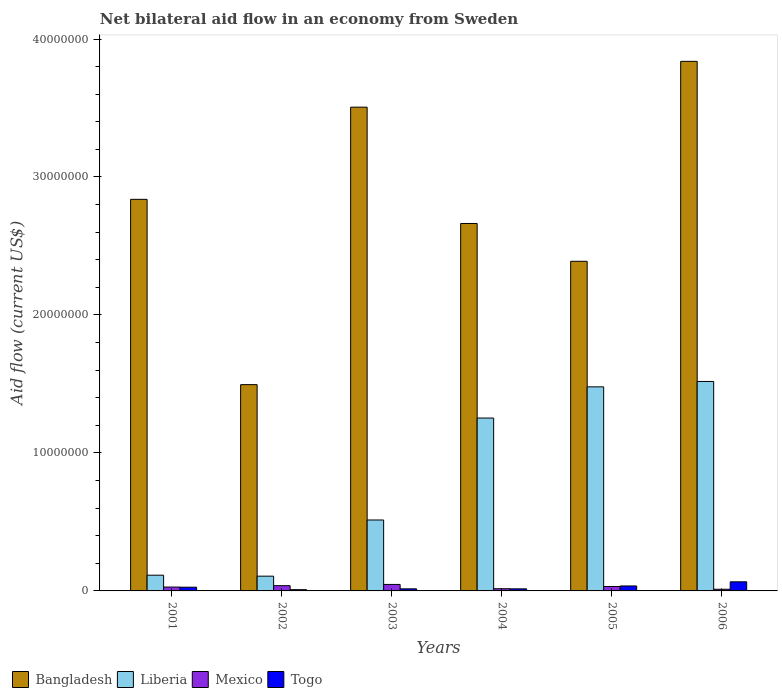How many different coloured bars are there?
Ensure brevity in your answer.  4. How many groups of bars are there?
Your answer should be very brief. 6. Are the number of bars per tick equal to the number of legend labels?
Give a very brief answer. Yes. Are the number of bars on each tick of the X-axis equal?
Your answer should be very brief. Yes. How many bars are there on the 6th tick from the left?
Your response must be concise. 4. How many bars are there on the 2nd tick from the right?
Keep it short and to the point. 4. In how many cases, is the number of bars for a given year not equal to the number of legend labels?
Provide a short and direct response. 0. What is the net bilateral aid flow in Bangladesh in 2003?
Your answer should be compact. 3.51e+07. Across all years, what is the maximum net bilateral aid flow in Mexico?
Offer a very short reply. 4.70e+05. In which year was the net bilateral aid flow in Bangladesh minimum?
Your answer should be compact. 2002. What is the total net bilateral aid flow in Mexico in the graph?
Offer a very short reply. 1.73e+06. What is the difference between the net bilateral aid flow in Togo in 2001 and that in 2006?
Your answer should be very brief. -3.90e+05. What is the difference between the net bilateral aid flow in Mexico in 2001 and the net bilateral aid flow in Togo in 2006?
Give a very brief answer. -3.80e+05. What is the average net bilateral aid flow in Bangladesh per year?
Make the answer very short. 2.79e+07. In the year 2001, what is the difference between the net bilateral aid flow in Mexico and net bilateral aid flow in Bangladesh?
Your answer should be very brief. -2.81e+07. In how many years, is the net bilateral aid flow in Mexico greater than 20000000 US$?
Keep it short and to the point. 0. What is the ratio of the net bilateral aid flow in Bangladesh in 2001 to that in 2003?
Provide a succinct answer. 0.81. Is the net bilateral aid flow in Togo in 2001 less than that in 2005?
Keep it short and to the point. Yes. What is the difference between the highest and the second highest net bilateral aid flow in Bangladesh?
Give a very brief answer. 3.32e+06. What is the difference between the highest and the lowest net bilateral aid flow in Togo?
Offer a very short reply. 5.70e+05. Is the sum of the net bilateral aid flow in Liberia in 2001 and 2004 greater than the maximum net bilateral aid flow in Mexico across all years?
Make the answer very short. Yes. What does the 1st bar from the left in 2004 represents?
Your answer should be compact. Bangladesh. Is it the case that in every year, the sum of the net bilateral aid flow in Togo and net bilateral aid flow in Liberia is greater than the net bilateral aid flow in Bangladesh?
Your answer should be very brief. No. Are all the bars in the graph horizontal?
Provide a short and direct response. No. Are the values on the major ticks of Y-axis written in scientific E-notation?
Your answer should be very brief. No. Where does the legend appear in the graph?
Your answer should be very brief. Bottom left. How many legend labels are there?
Provide a succinct answer. 4. How are the legend labels stacked?
Offer a terse response. Horizontal. What is the title of the graph?
Your answer should be compact. Net bilateral aid flow in an economy from Sweden. What is the label or title of the Y-axis?
Ensure brevity in your answer.  Aid flow (current US$). What is the Aid flow (current US$) of Bangladesh in 2001?
Your answer should be very brief. 2.84e+07. What is the Aid flow (current US$) of Liberia in 2001?
Make the answer very short. 1.14e+06. What is the Aid flow (current US$) of Bangladesh in 2002?
Offer a terse response. 1.50e+07. What is the Aid flow (current US$) of Liberia in 2002?
Give a very brief answer. 1.07e+06. What is the Aid flow (current US$) of Mexico in 2002?
Your answer should be compact. 3.80e+05. What is the Aid flow (current US$) of Togo in 2002?
Provide a short and direct response. 9.00e+04. What is the Aid flow (current US$) in Bangladesh in 2003?
Offer a terse response. 3.51e+07. What is the Aid flow (current US$) in Liberia in 2003?
Your response must be concise. 5.14e+06. What is the Aid flow (current US$) in Togo in 2003?
Provide a short and direct response. 1.50e+05. What is the Aid flow (current US$) of Bangladesh in 2004?
Your answer should be compact. 2.66e+07. What is the Aid flow (current US$) of Liberia in 2004?
Your answer should be compact. 1.25e+07. What is the Aid flow (current US$) of Bangladesh in 2005?
Your answer should be compact. 2.39e+07. What is the Aid flow (current US$) in Liberia in 2005?
Make the answer very short. 1.48e+07. What is the Aid flow (current US$) in Mexico in 2005?
Your answer should be compact. 3.20e+05. What is the Aid flow (current US$) of Bangladesh in 2006?
Your answer should be very brief. 3.84e+07. What is the Aid flow (current US$) of Liberia in 2006?
Your answer should be compact. 1.52e+07. What is the Aid flow (current US$) of Mexico in 2006?
Your response must be concise. 1.20e+05. Across all years, what is the maximum Aid flow (current US$) in Bangladesh?
Provide a short and direct response. 3.84e+07. Across all years, what is the maximum Aid flow (current US$) in Liberia?
Your response must be concise. 1.52e+07. Across all years, what is the maximum Aid flow (current US$) of Mexico?
Your response must be concise. 4.70e+05. Across all years, what is the minimum Aid flow (current US$) in Bangladesh?
Offer a terse response. 1.50e+07. Across all years, what is the minimum Aid flow (current US$) of Liberia?
Provide a short and direct response. 1.07e+06. Across all years, what is the minimum Aid flow (current US$) of Togo?
Ensure brevity in your answer.  9.00e+04. What is the total Aid flow (current US$) in Bangladesh in the graph?
Offer a very short reply. 1.67e+08. What is the total Aid flow (current US$) in Liberia in the graph?
Offer a very short reply. 4.98e+07. What is the total Aid flow (current US$) in Mexico in the graph?
Provide a succinct answer. 1.73e+06. What is the total Aid flow (current US$) of Togo in the graph?
Keep it short and to the point. 1.68e+06. What is the difference between the Aid flow (current US$) of Bangladesh in 2001 and that in 2002?
Provide a short and direct response. 1.34e+07. What is the difference between the Aid flow (current US$) in Liberia in 2001 and that in 2002?
Give a very brief answer. 7.00e+04. What is the difference between the Aid flow (current US$) of Mexico in 2001 and that in 2002?
Make the answer very short. -1.00e+05. What is the difference between the Aid flow (current US$) of Bangladesh in 2001 and that in 2003?
Your answer should be very brief. -6.68e+06. What is the difference between the Aid flow (current US$) of Mexico in 2001 and that in 2003?
Your response must be concise. -1.90e+05. What is the difference between the Aid flow (current US$) of Togo in 2001 and that in 2003?
Your answer should be very brief. 1.20e+05. What is the difference between the Aid flow (current US$) in Bangladesh in 2001 and that in 2004?
Provide a succinct answer. 1.75e+06. What is the difference between the Aid flow (current US$) in Liberia in 2001 and that in 2004?
Ensure brevity in your answer.  -1.14e+07. What is the difference between the Aid flow (current US$) of Mexico in 2001 and that in 2004?
Offer a very short reply. 1.20e+05. What is the difference between the Aid flow (current US$) of Bangladesh in 2001 and that in 2005?
Ensure brevity in your answer.  4.49e+06. What is the difference between the Aid flow (current US$) of Liberia in 2001 and that in 2005?
Your answer should be very brief. -1.36e+07. What is the difference between the Aid flow (current US$) in Bangladesh in 2001 and that in 2006?
Provide a short and direct response. -1.00e+07. What is the difference between the Aid flow (current US$) in Liberia in 2001 and that in 2006?
Provide a succinct answer. -1.40e+07. What is the difference between the Aid flow (current US$) of Togo in 2001 and that in 2006?
Your response must be concise. -3.90e+05. What is the difference between the Aid flow (current US$) in Bangladesh in 2002 and that in 2003?
Your response must be concise. -2.01e+07. What is the difference between the Aid flow (current US$) of Liberia in 2002 and that in 2003?
Offer a very short reply. -4.07e+06. What is the difference between the Aid flow (current US$) of Bangladesh in 2002 and that in 2004?
Make the answer very short. -1.17e+07. What is the difference between the Aid flow (current US$) in Liberia in 2002 and that in 2004?
Give a very brief answer. -1.15e+07. What is the difference between the Aid flow (current US$) of Mexico in 2002 and that in 2004?
Provide a succinct answer. 2.20e+05. What is the difference between the Aid flow (current US$) of Togo in 2002 and that in 2004?
Make the answer very short. -6.00e+04. What is the difference between the Aid flow (current US$) in Bangladesh in 2002 and that in 2005?
Ensure brevity in your answer.  -8.94e+06. What is the difference between the Aid flow (current US$) of Liberia in 2002 and that in 2005?
Make the answer very short. -1.37e+07. What is the difference between the Aid flow (current US$) of Bangladesh in 2002 and that in 2006?
Provide a succinct answer. -2.34e+07. What is the difference between the Aid flow (current US$) of Liberia in 2002 and that in 2006?
Offer a very short reply. -1.41e+07. What is the difference between the Aid flow (current US$) of Mexico in 2002 and that in 2006?
Your response must be concise. 2.60e+05. What is the difference between the Aid flow (current US$) in Togo in 2002 and that in 2006?
Provide a succinct answer. -5.70e+05. What is the difference between the Aid flow (current US$) of Bangladesh in 2003 and that in 2004?
Your answer should be very brief. 8.43e+06. What is the difference between the Aid flow (current US$) in Liberia in 2003 and that in 2004?
Your answer should be very brief. -7.39e+06. What is the difference between the Aid flow (current US$) of Mexico in 2003 and that in 2004?
Offer a very short reply. 3.10e+05. What is the difference between the Aid flow (current US$) in Bangladesh in 2003 and that in 2005?
Keep it short and to the point. 1.12e+07. What is the difference between the Aid flow (current US$) in Liberia in 2003 and that in 2005?
Your response must be concise. -9.65e+06. What is the difference between the Aid flow (current US$) of Mexico in 2003 and that in 2005?
Make the answer very short. 1.50e+05. What is the difference between the Aid flow (current US$) of Bangladesh in 2003 and that in 2006?
Provide a short and direct response. -3.32e+06. What is the difference between the Aid flow (current US$) in Liberia in 2003 and that in 2006?
Ensure brevity in your answer.  -1.00e+07. What is the difference between the Aid flow (current US$) of Mexico in 2003 and that in 2006?
Your answer should be very brief. 3.50e+05. What is the difference between the Aid flow (current US$) of Togo in 2003 and that in 2006?
Offer a terse response. -5.10e+05. What is the difference between the Aid flow (current US$) in Bangladesh in 2004 and that in 2005?
Your answer should be very brief. 2.74e+06. What is the difference between the Aid flow (current US$) of Liberia in 2004 and that in 2005?
Offer a very short reply. -2.26e+06. What is the difference between the Aid flow (current US$) of Mexico in 2004 and that in 2005?
Offer a terse response. -1.60e+05. What is the difference between the Aid flow (current US$) in Bangladesh in 2004 and that in 2006?
Ensure brevity in your answer.  -1.18e+07. What is the difference between the Aid flow (current US$) in Liberia in 2004 and that in 2006?
Ensure brevity in your answer.  -2.65e+06. What is the difference between the Aid flow (current US$) in Mexico in 2004 and that in 2006?
Ensure brevity in your answer.  4.00e+04. What is the difference between the Aid flow (current US$) in Togo in 2004 and that in 2006?
Offer a very short reply. -5.10e+05. What is the difference between the Aid flow (current US$) in Bangladesh in 2005 and that in 2006?
Your answer should be very brief. -1.45e+07. What is the difference between the Aid flow (current US$) in Liberia in 2005 and that in 2006?
Offer a very short reply. -3.90e+05. What is the difference between the Aid flow (current US$) in Bangladesh in 2001 and the Aid flow (current US$) in Liberia in 2002?
Your response must be concise. 2.73e+07. What is the difference between the Aid flow (current US$) of Bangladesh in 2001 and the Aid flow (current US$) of Mexico in 2002?
Ensure brevity in your answer.  2.80e+07. What is the difference between the Aid flow (current US$) of Bangladesh in 2001 and the Aid flow (current US$) of Togo in 2002?
Make the answer very short. 2.83e+07. What is the difference between the Aid flow (current US$) of Liberia in 2001 and the Aid flow (current US$) of Mexico in 2002?
Offer a very short reply. 7.60e+05. What is the difference between the Aid flow (current US$) of Liberia in 2001 and the Aid flow (current US$) of Togo in 2002?
Make the answer very short. 1.05e+06. What is the difference between the Aid flow (current US$) in Mexico in 2001 and the Aid flow (current US$) in Togo in 2002?
Ensure brevity in your answer.  1.90e+05. What is the difference between the Aid flow (current US$) in Bangladesh in 2001 and the Aid flow (current US$) in Liberia in 2003?
Offer a terse response. 2.32e+07. What is the difference between the Aid flow (current US$) in Bangladesh in 2001 and the Aid flow (current US$) in Mexico in 2003?
Provide a short and direct response. 2.79e+07. What is the difference between the Aid flow (current US$) of Bangladesh in 2001 and the Aid flow (current US$) of Togo in 2003?
Keep it short and to the point. 2.82e+07. What is the difference between the Aid flow (current US$) in Liberia in 2001 and the Aid flow (current US$) in Mexico in 2003?
Provide a succinct answer. 6.70e+05. What is the difference between the Aid flow (current US$) of Liberia in 2001 and the Aid flow (current US$) of Togo in 2003?
Your response must be concise. 9.90e+05. What is the difference between the Aid flow (current US$) of Mexico in 2001 and the Aid flow (current US$) of Togo in 2003?
Provide a succinct answer. 1.30e+05. What is the difference between the Aid flow (current US$) in Bangladesh in 2001 and the Aid flow (current US$) in Liberia in 2004?
Offer a terse response. 1.58e+07. What is the difference between the Aid flow (current US$) of Bangladesh in 2001 and the Aid flow (current US$) of Mexico in 2004?
Your answer should be very brief. 2.82e+07. What is the difference between the Aid flow (current US$) in Bangladesh in 2001 and the Aid flow (current US$) in Togo in 2004?
Your response must be concise. 2.82e+07. What is the difference between the Aid flow (current US$) of Liberia in 2001 and the Aid flow (current US$) of Mexico in 2004?
Provide a short and direct response. 9.80e+05. What is the difference between the Aid flow (current US$) of Liberia in 2001 and the Aid flow (current US$) of Togo in 2004?
Offer a terse response. 9.90e+05. What is the difference between the Aid flow (current US$) in Bangladesh in 2001 and the Aid flow (current US$) in Liberia in 2005?
Your answer should be compact. 1.36e+07. What is the difference between the Aid flow (current US$) in Bangladesh in 2001 and the Aid flow (current US$) in Mexico in 2005?
Provide a short and direct response. 2.81e+07. What is the difference between the Aid flow (current US$) of Bangladesh in 2001 and the Aid flow (current US$) of Togo in 2005?
Keep it short and to the point. 2.80e+07. What is the difference between the Aid flow (current US$) in Liberia in 2001 and the Aid flow (current US$) in Mexico in 2005?
Provide a succinct answer. 8.20e+05. What is the difference between the Aid flow (current US$) in Liberia in 2001 and the Aid flow (current US$) in Togo in 2005?
Keep it short and to the point. 7.80e+05. What is the difference between the Aid flow (current US$) of Mexico in 2001 and the Aid flow (current US$) of Togo in 2005?
Give a very brief answer. -8.00e+04. What is the difference between the Aid flow (current US$) of Bangladesh in 2001 and the Aid flow (current US$) of Liberia in 2006?
Your answer should be compact. 1.32e+07. What is the difference between the Aid flow (current US$) of Bangladesh in 2001 and the Aid flow (current US$) of Mexico in 2006?
Make the answer very short. 2.83e+07. What is the difference between the Aid flow (current US$) of Bangladesh in 2001 and the Aid flow (current US$) of Togo in 2006?
Your response must be concise. 2.77e+07. What is the difference between the Aid flow (current US$) of Liberia in 2001 and the Aid flow (current US$) of Mexico in 2006?
Keep it short and to the point. 1.02e+06. What is the difference between the Aid flow (current US$) in Mexico in 2001 and the Aid flow (current US$) in Togo in 2006?
Your answer should be very brief. -3.80e+05. What is the difference between the Aid flow (current US$) in Bangladesh in 2002 and the Aid flow (current US$) in Liberia in 2003?
Make the answer very short. 9.81e+06. What is the difference between the Aid flow (current US$) of Bangladesh in 2002 and the Aid flow (current US$) of Mexico in 2003?
Offer a very short reply. 1.45e+07. What is the difference between the Aid flow (current US$) of Bangladesh in 2002 and the Aid flow (current US$) of Togo in 2003?
Your response must be concise. 1.48e+07. What is the difference between the Aid flow (current US$) of Liberia in 2002 and the Aid flow (current US$) of Mexico in 2003?
Provide a succinct answer. 6.00e+05. What is the difference between the Aid flow (current US$) of Liberia in 2002 and the Aid flow (current US$) of Togo in 2003?
Ensure brevity in your answer.  9.20e+05. What is the difference between the Aid flow (current US$) in Mexico in 2002 and the Aid flow (current US$) in Togo in 2003?
Ensure brevity in your answer.  2.30e+05. What is the difference between the Aid flow (current US$) of Bangladesh in 2002 and the Aid flow (current US$) of Liberia in 2004?
Your response must be concise. 2.42e+06. What is the difference between the Aid flow (current US$) of Bangladesh in 2002 and the Aid flow (current US$) of Mexico in 2004?
Ensure brevity in your answer.  1.48e+07. What is the difference between the Aid flow (current US$) of Bangladesh in 2002 and the Aid flow (current US$) of Togo in 2004?
Keep it short and to the point. 1.48e+07. What is the difference between the Aid flow (current US$) of Liberia in 2002 and the Aid flow (current US$) of Mexico in 2004?
Keep it short and to the point. 9.10e+05. What is the difference between the Aid flow (current US$) of Liberia in 2002 and the Aid flow (current US$) of Togo in 2004?
Ensure brevity in your answer.  9.20e+05. What is the difference between the Aid flow (current US$) in Mexico in 2002 and the Aid flow (current US$) in Togo in 2004?
Your answer should be very brief. 2.30e+05. What is the difference between the Aid flow (current US$) in Bangladesh in 2002 and the Aid flow (current US$) in Liberia in 2005?
Your answer should be very brief. 1.60e+05. What is the difference between the Aid flow (current US$) in Bangladesh in 2002 and the Aid flow (current US$) in Mexico in 2005?
Give a very brief answer. 1.46e+07. What is the difference between the Aid flow (current US$) of Bangladesh in 2002 and the Aid flow (current US$) of Togo in 2005?
Offer a terse response. 1.46e+07. What is the difference between the Aid flow (current US$) of Liberia in 2002 and the Aid flow (current US$) of Mexico in 2005?
Your answer should be very brief. 7.50e+05. What is the difference between the Aid flow (current US$) of Liberia in 2002 and the Aid flow (current US$) of Togo in 2005?
Your response must be concise. 7.10e+05. What is the difference between the Aid flow (current US$) of Mexico in 2002 and the Aid flow (current US$) of Togo in 2005?
Your response must be concise. 2.00e+04. What is the difference between the Aid flow (current US$) of Bangladesh in 2002 and the Aid flow (current US$) of Mexico in 2006?
Your answer should be very brief. 1.48e+07. What is the difference between the Aid flow (current US$) of Bangladesh in 2002 and the Aid flow (current US$) of Togo in 2006?
Give a very brief answer. 1.43e+07. What is the difference between the Aid flow (current US$) in Liberia in 2002 and the Aid flow (current US$) in Mexico in 2006?
Your response must be concise. 9.50e+05. What is the difference between the Aid flow (current US$) in Liberia in 2002 and the Aid flow (current US$) in Togo in 2006?
Give a very brief answer. 4.10e+05. What is the difference between the Aid flow (current US$) of Mexico in 2002 and the Aid flow (current US$) of Togo in 2006?
Give a very brief answer. -2.80e+05. What is the difference between the Aid flow (current US$) in Bangladesh in 2003 and the Aid flow (current US$) in Liberia in 2004?
Offer a very short reply. 2.25e+07. What is the difference between the Aid flow (current US$) in Bangladesh in 2003 and the Aid flow (current US$) in Mexico in 2004?
Offer a very short reply. 3.49e+07. What is the difference between the Aid flow (current US$) in Bangladesh in 2003 and the Aid flow (current US$) in Togo in 2004?
Offer a terse response. 3.49e+07. What is the difference between the Aid flow (current US$) of Liberia in 2003 and the Aid flow (current US$) of Mexico in 2004?
Your response must be concise. 4.98e+06. What is the difference between the Aid flow (current US$) of Liberia in 2003 and the Aid flow (current US$) of Togo in 2004?
Provide a short and direct response. 4.99e+06. What is the difference between the Aid flow (current US$) of Mexico in 2003 and the Aid flow (current US$) of Togo in 2004?
Make the answer very short. 3.20e+05. What is the difference between the Aid flow (current US$) in Bangladesh in 2003 and the Aid flow (current US$) in Liberia in 2005?
Your response must be concise. 2.03e+07. What is the difference between the Aid flow (current US$) in Bangladesh in 2003 and the Aid flow (current US$) in Mexico in 2005?
Your answer should be compact. 3.47e+07. What is the difference between the Aid flow (current US$) in Bangladesh in 2003 and the Aid flow (current US$) in Togo in 2005?
Your answer should be very brief. 3.47e+07. What is the difference between the Aid flow (current US$) of Liberia in 2003 and the Aid flow (current US$) of Mexico in 2005?
Offer a very short reply. 4.82e+06. What is the difference between the Aid flow (current US$) of Liberia in 2003 and the Aid flow (current US$) of Togo in 2005?
Offer a very short reply. 4.78e+06. What is the difference between the Aid flow (current US$) of Bangladesh in 2003 and the Aid flow (current US$) of Liberia in 2006?
Provide a short and direct response. 1.99e+07. What is the difference between the Aid flow (current US$) of Bangladesh in 2003 and the Aid flow (current US$) of Mexico in 2006?
Ensure brevity in your answer.  3.49e+07. What is the difference between the Aid flow (current US$) of Bangladesh in 2003 and the Aid flow (current US$) of Togo in 2006?
Your answer should be compact. 3.44e+07. What is the difference between the Aid flow (current US$) of Liberia in 2003 and the Aid flow (current US$) of Mexico in 2006?
Make the answer very short. 5.02e+06. What is the difference between the Aid flow (current US$) in Liberia in 2003 and the Aid flow (current US$) in Togo in 2006?
Offer a very short reply. 4.48e+06. What is the difference between the Aid flow (current US$) in Mexico in 2003 and the Aid flow (current US$) in Togo in 2006?
Give a very brief answer. -1.90e+05. What is the difference between the Aid flow (current US$) in Bangladesh in 2004 and the Aid flow (current US$) in Liberia in 2005?
Your answer should be very brief. 1.18e+07. What is the difference between the Aid flow (current US$) of Bangladesh in 2004 and the Aid flow (current US$) of Mexico in 2005?
Keep it short and to the point. 2.63e+07. What is the difference between the Aid flow (current US$) of Bangladesh in 2004 and the Aid flow (current US$) of Togo in 2005?
Make the answer very short. 2.63e+07. What is the difference between the Aid flow (current US$) of Liberia in 2004 and the Aid flow (current US$) of Mexico in 2005?
Provide a short and direct response. 1.22e+07. What is the difference between the Aid flow (current US$) of Liberia in 2004 and the Aid flow (current US$) of Togo in 2005?
Provide a short and direct response. 1.22e+07. What is the difference between the Aid flow (current US$) in Mexico in 2004 and the Aid flow (current US$) in Togo in 2005?
Ensure brevity in your answer.  -2.00e+05. What is the difference between the Aid flow (current US$) in Bangladesh in 2004 and the Aid flow (current US$) in Liberia in 2006?
Offer a very short reply. 1.14e+07. What is the difference between the Aid flow (current US$) in Bangladesh in 2004 and the Aid flow (current US$) in Mexico in 2006?
Offer a terse response. 2.65e+07. What is the difference between the Aid flow (current US$) in Bangladesh in 2004 and the Aid flow (current US$) in Togo in 2006?
Ensure brevity in your answer.  2.60e+07. What is the difference between the Aid flow (current US$) in Liberia in 2004 and the Aid flow (current US$) in Mexico in 2006?
Give a very brief answer. 1.24e+07. What is the difference between the Aid flow (current US$) in Liberia in 2004 and the Aid flow (current US$) in Togo in 2006?
Keep it short and to the point. 1.19e+07. What is the difference between the Aid flow (current US$) of Mexico in 2004 and the Aid flow (current US$) of Togo in 2006?
Provide a short and direct response. -5.00e+05. What is the difference between the Aid flow (current US$) of Bangladesh in 2005 and the Aid flow (current US$) of Liberia in 2006?
Provide a short and direct response. 8.71e+06. What is the difference between the Aid flow (current US$) of Bangladesh in 2005 and the Aid flow (current US$) of Mexico in 2006?
Offer a very short reply. 2.38e+07. What is the difference between the Aid flow (current US$) in Bangladesh in 2005 and the Aid flow (current US$) in Togo in 2006?
Provide a short and direct response. 2.32e+07. What is the difference between the Aid flow (current US$) of Liberia in 2005 and the Aid flow (current US$) of Mexico in 2006?
Ensure brevity in your answer.  1.47e+07. What is the difference between the Aid flow (current US$) in Liberia in 2005 and the Aid flow (current US$) in Togo in 2006?
Keep it short and to the point. 1.41e+07. What is the difference between the Aid flow (current US$) in Mexico in 2005 and the Aid flow (current US$) in Togo in 2006?
Offer a very short reply. -3.40e+05. What is the average Aid flow (current US$) of Bangladesh per year?
Provide a short and direct response. 2.79e+07. What is the average Aid flow (current US$) of Liberia per year?
Keep it short and to the point. 8.31e+06. What is the average Aid flow (current US$) of Mexico per year?
Your answer should be compact. 2.88e+05. In the year 2001, what is the difference between the Aid flow (current US$) in Bangladesh and Aid flow (current US$) in Liberia?
Your answer should be very brief. 2.72e+07. In the year 2001, what is the difference between the Aid flow (current US$) of Bangladesh and Aid flow (current US$) of Mexico?
Offer a terse response. 2.81e+07. In the year 2001, what is the difference between the Aid flow (current US$) of Bangladesh and Aid flow (current US$) of Togo?
Your answer should be compact. 2.81e+07. In the year 2001, what is the difference between the Aid flow (current US$) in Liberia and Aid flow (current US$) in Mexico?
Your answer should be compact. 8.60e+05. In the year 2001, what is the difference between the Aid flow (current US$) in Liberia and Aid flow (current US$) in Togo?
Offer a terse response. 8.70e+05. In the year 2001, what is the difference between the Aid flow (current US$) in Mexico and Aid flow (current US$) in Togo?
Your answer should be compact. 10000. In the year 2002, what is the difference between the Aid flow (current US$) of Bangladesh and Aid flow (current US$) of Liberia?
Offer a terse response. 1.39e+07. In the year 2002, what is the difference between the Aid flow (current US$) in Bangladesh and Aid flow (current US$) in Mexico?
Keep it short and to the point. 1.46e+07. In the year 2002, what is the difference between the Aid flow (current US$) in Bangladesh and Aid flow (current US$) in Togo?
Offer a very short reply. 1.49e+07. In the year 2002, what is the difference between the Aid flow (current US$) of Liberia and Aid flow (current US$) of Mexico?
Give a very brief answer. 6.90e+05. In the year 2002, what is the difference between the Aid flow (current US$) in Liberia and Aid flow (current US$) in Togo?
Provide a succinct answer. 9.80e+05. In the year 2002, what is the difference between the Aid flow (current US$) of Mexico and Aid flow (current US$) of Togo?
Make the answer very short. 2.90e+05. In the year 2003, what is the difference between the Aid flow (current US$) in Bangladesh and Aid flow (current US$) in Liberia?
Provide a short and direct response. 2.99e+07. In the year 2003, what is the difference between the Aid flow (current US$) of Bangladesh and Aid flow (current US$) of Mexico?
Provide a short and direct response. 3.46e+07. In the year 2003, what is the difference between the Aid flow (current US$) in Bangladesh and Aid flow (current US$) in Togo?
Offer a very short reply. 3.49e+07. In the year 2003, what is the difference between the Aid flow (current US$) of Liberia and Aid flow (current US$) of Mexico?
Your answer should be very brief. 4.67e+06. In the year 2003, what is the difference between the Aid flow (current US$) in Liberia and Aid flow (current US$) in Togo?
Provide a short and direct response. 4.99e+06. In the year 2004, what is the difference between the Aid flow (current US$) of Bangladesh and Aid flow (current US$) of Liberia?
Your answer should be very brief. 1.41e+07. In the year 2004, what is the difference between the Aid flow (current US$) in Bangladesh and Aid flow (current US$) in Mexico?
Offer a terse response. 2.65e+07. In the year 2004, what is the difference between the Aid flow (current US$) of Bangladesh and Aid flow (current US$) of Togo?
Provide a succinct answer. 2.65e+07. In the year 2004, what is the difference between the Aid flow (current US$) of Liberia and Aid flow (current US$) of Mexico?
Make the answer very short. 1.24e+07. In the year 2004, what is the difference between the Aid flow (current US$) of Liberia and Aid flow (current US$) of Togo?
Make the answer very short. 1.24e+07. In the year 2005, what is the difference between the Aid flow (current US$) in Bangladesh and Aid flow (current US$) in Liberia?
Provide a succinct answer. 9.10e+06. In the year 2005, what is the difference between the Aid flow (current US$) of Bangladesh and Aid flow (current US$) of Mexico?
Provide a succinct answer. 2.36e+07. In the year 2005, what is the difference between the Aid flow (current US$) of Bangladesh and Aid flow (current US$) of Togo?
Offer a very short reply. 2.35e+07. In the year 2005, what is the difference between the Aid flow (current US$) of Liberia and Aid flow (current US$) of Mexico?
Your response must be concise. 1.45e+07. In the year 2005, what is the difference between the Aid flow (current US$) in Liberia and Aid flow (current US$) in Togo?
Your answer should be very brief. 1.44e+07. In the year 2006, what is the difference between the Aid flow (current US$) of Bangladesh and Aid flow (current US$) of Liberia?
Make the answer very short. 2.32e+07. In the year 2006, what is the difference between the Aid flow (current US$) of Bangladesh and Aid flow (current US$) of Mexico?
Provide a succinct answer. 3.83e+07. In the year 2006, what is the difference between the Aid flow (current US$) in Bangladesh and Aid flow (current US$) in Togo?
Give a very brief answer. 3.77e+07. In the year 2006, what is the difference between the Aid flow (current US$) of Liberia and Aid flow (current US$) of Mexico?
Keep it short and to the point. 1.51e+07. In the year 2006, what is the difference between the Aid flow (current US$) of Liberia and Aid flow (current US$) of Togo?
Offer a terse response. 1.45e+07. In the year 2006, what is the difference between the Aid flow (current US$) in Mexico and Aid flow (current US$) in Togo?
Your answer should be compact. -5.40e+05. What is the ratio of the Aid flow (current US$) of Bangladesh in 2001 to that in 2002?
Give a very brief answer. 1.9. What is the ratio of the Aid flow (current US$) of Liberia in 2001 to that in 2002?
Your answer should be very brief. 1.07. What is the ratio of the Aid flow (current US$) in Mexico in 2001 to that in 2002?
Provide a short and direct response. 0.74. What is the ratio of the Aid flow (current US$) of Togo in 2001 to that in 2002?
Provide a succinct answer. 3. What is the ratio of the Aid flow (current US$) in Bangladesh in 2001 to that in 2003?
Your answer should be very brief. 0.81. What is the ratio of the Aid flow (current US$) of Liberia in 2001 to that in 2003?
Keep it short and to the point. 0.22. What is the ratio of the Aid flow (current US$) in Mexico in 2001 to that in 2003?
Keep it short and to the point. 0.6. What is the ratio of the Aid flow (current US$) of Bangladesh in 2001 to that in 2004?
Keep it short and to the point. 1.07. What is the ratio of the Aid flow (current US$) in Liberia in 2001 to that in 2004?
Your answer should be compact. 0.09. What is the ratio of the Aid flow (current US$) in Bangladesh in 2001 to that in 2005?
Provide a succinct answer. 1.19. What is the ratio of the Aid flow (current US$) in Liberia in 2001 to that in 2005?
Make the answer very short. 0.08. What is the ratio of the Aid flow (current US$) of Togo in 2001 to that in 2005?
Offer a terse response. 0.75. What is the ratio of the Aid flow (current US$) of Bangladesh in 2001 to that in 2006?
Ensure brevity in your answer.  0.74. What is the ratio of the Aid flow (current US$) of Liberia in 2001 to that in 2006?
Ensure brevity in your answer.  0.08. What is the ratio of the Aid flow (current US$) in Mexico in 2001 to that in 2006?
Make the answer very short. 2.33. What is the ratio of the Aid flow (current US$) of Togo in 2001 to that in 2006?
Provide a succinct answer. 0.41. What is the ratio of the Aid flow (current US$) in Bangladesh in 2002 to that in 2003?
Provide a succinct answer. 0.43. What is the ratio of the Aid flow (current US$) of Liberia in 2002 to that in 2003?
Your answer should be compact. 0.21. What is the ratio of the Aid flow (current US$) of Mexico in 2002 to that in 2003?
Make the answer very short. 0.81. What is the ratio of the Aid flow (current US$) in Togo in 2002 to that in 2003?
Make the answer very short. 0.6. What is the ratio of the Aid flow (current US$) of Bangladesh in 2002 to that in 2004?
Your answer should be compact. 0.56. What is the ratio of the Aid flow (current US$) of Liberia in 2002 to that in 2004?
Your answer should be compact. 0.09. What is the ratio of the Aid flow (current US$) in Mexico in 2002 to that in 2004?
Ensure brevity in your answer.  2.38. What is the ratio of the Aid flow (current US$) in Bangladesh in 2002 to that in 2005?
Give a very brief answer. 0.63. What is the ratio of the Aid flow (current US$) in Liberia in 2002 to that in 2005?
Offer a very short reply. 0.07. What is the ratio of the Aid flow (current US$) of Mexico in 2002 to that in 2005?
Your answer should be very brief. 1.19. What is the ratio of the Aid flow (current US$) of Togo in 2002 to that in 2005?
Give a very brief answer. 0.25. What is the ratio of the Aid flow (current US$) of Bangladesh in 2002 to that in 2006?
Offer a terse response. 0.39. What is the ratio of the Aid flow (current US$) of Liberia in 2002 to that in 2006?
Ensure brevity in your answer.  0.07. What is the ratio of the Aid flow (current US$) in Mexico in 2002 to that in 2006?
Ensure brevity in your answer.  3.17. What is the ratio of the Aid flow (current US$) of Togo in 2002 to that in 2006?
Keep it short and to the point. 0.14. What is the ratio of the Aid flow (current US$) of Bangladesh in 2003 to that in 2004?
Your response must be concise. 1.32. What is the ratio of the Aid flow (current US$) in Liberia in 2003 to that in 2004?
Keep it short and to the point. 0.41. What is the ratio of the Aid flow (current US$) of Mexico in 2003 to that in 2004?
Your answer should be very brief. 2.94. What is the ratio of the Aid flow (current US$) of Togo in 2003 to that in 2004?
Ensure brevity in your answer.  1. What is the ratio of the Aid flow (current US$) in Bangladesh in 2003 to that in 2005?
Offer a very short reply. 1.47. What is the ratio of the Aid flow (current US$) of Liberia in 2003 to that in 2005?
Ensure brevity in your answer.  0.35. What is the ratio of the Aid flow (current US$) of Mexico in 2003 to that in 2005?
Provide a short and direct response. 1.47. What is the ratio of the Aid flow (current US$) in Togo in 2003 to that in 2005?
Give a very brief answer. 0.42. What is the ratio of the Aid flow (current US$) of Bangladesh in 2003 to that in 2006?
Make the answer very short. 0.91. What is the ratio of the Aid flow (current US$) of Liberia in 2003 to that in 2006?
Your answer should be compact. 0.34. What is the ratio of the Aid flow (current US$) of Mexico in 2003 to that in 2006?
Your answer should be compact. 3.92. What is the ratio of the Aid flow (current US$) of Togo in 2003 to that in 2006?
Make the answer very short. 0.23. What is the ratio of the Aid flow (current US$) in Bangladesh in 2004 to that in 2005?
Your response must be concise. 1.11. What is the ratio of the Aid flow (current US$) of Liberia in 2004 to that in 2005?
Provide a short and direct response. 0.85. What is the ratio of the Aid flow (current US$) of Togo in 2004 to that in 2005?
Provide a short and direct response. 0.42. What is the ratio of the Aid flow (current US$) in Bangladesh in 2004 to that in 2006?
Keep it short and to the point. 0.69. What is the ratio of the Aid flow (current US$) of Liberia in 2004 to that in 2006?
Your answer should be very brief. 0.83. What is the ratio of the Aid flow (current US$) in Mexico in 2004 to that in 2006?
Ensure brevity in your answer.  1.33. What is the ratio of the Aid flow (current US$) in Togo in 2004 to that in 2006?
Provide a short and direct response. 0.23. What is the ratio of the Aid flow (current US$) in Bangladesh in 2005 to that in 2006?
Ensure brevity in your answer.  0.62. What is the ratio of the Aid flow (current US$) in Liberia in 2005 to that in 2006?
Ensure brevity in your answer.  0.97. What is the ratio of the Aid flow (current US$) in Mexico in 2005 to that in 2006?
Provide a short and direct response. 2.67. What is the ratio of the Aid flow (current US$) of Togo in 2005 to that in 2006?
Provide a succinct answer. 0.55. What is the difference between the highest and the second highest Aid flow (current US$) in Bangladesh?
Offer a terse response. 3.32e+06. What is the difference between the highest and the lowest Aid flow (current US$) in Bangladesh?
Make the answer very short. 2.34e+07. What is the difference between the highest and the lowest Aid flow (current US$) of Liberia?
Keep it short and to the point. 1.41e+07. What is the difference between the highest and the lowest Aid flow (current US$) in Togo?
Offer a very short reply. 5.70e+05. 